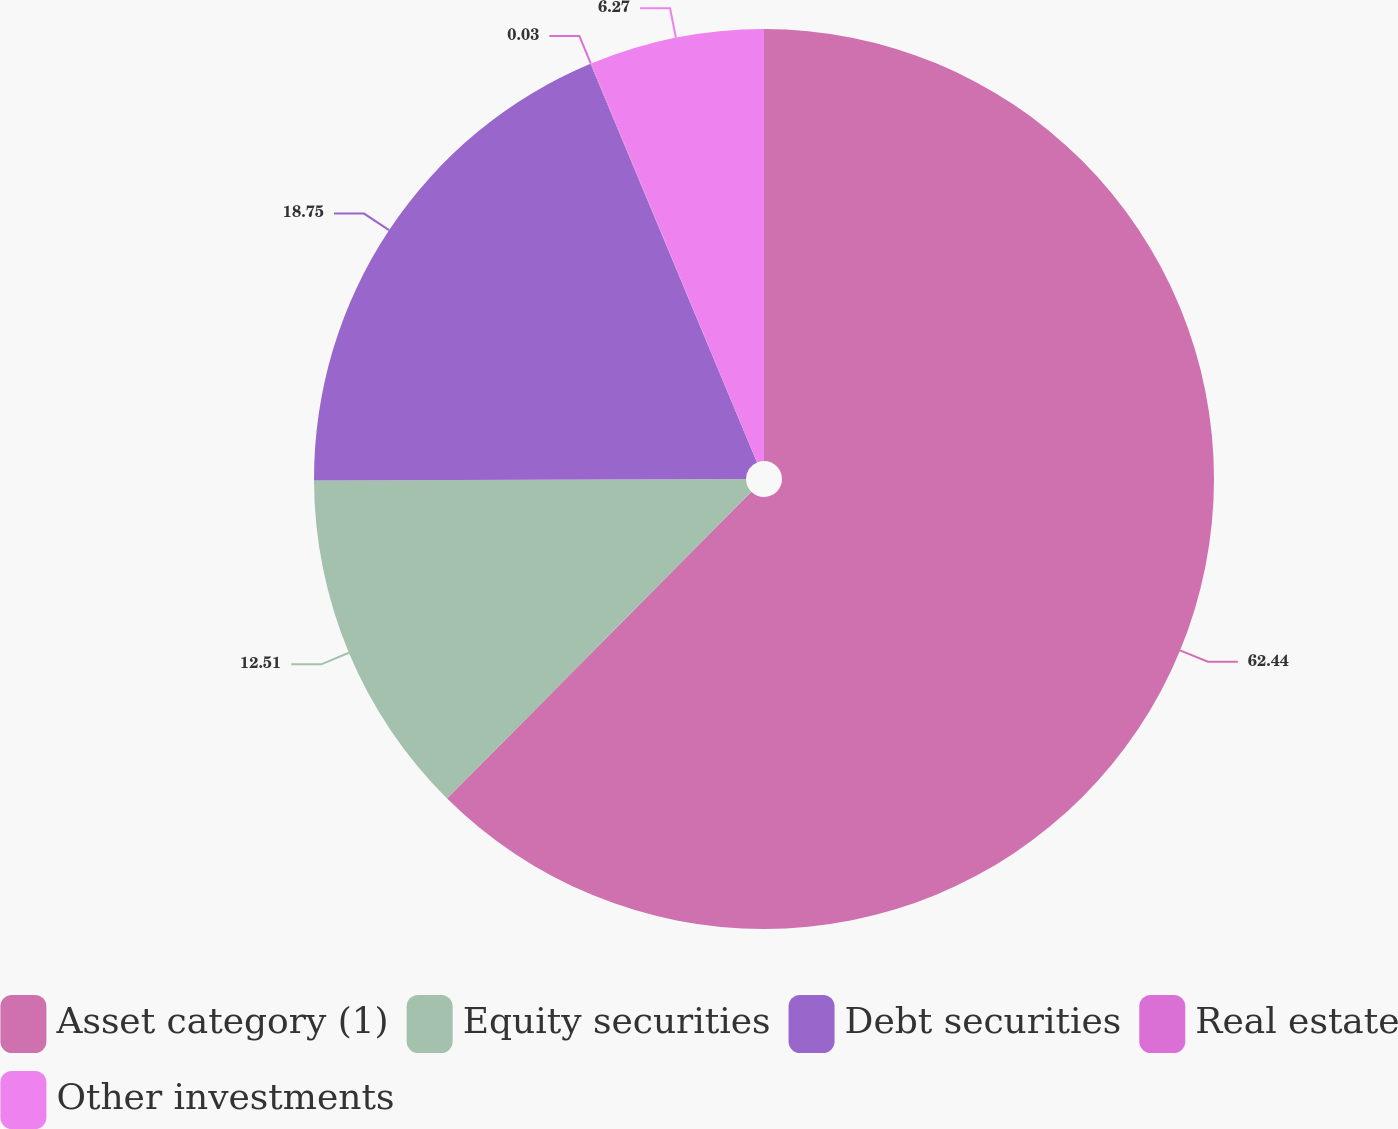<chart> <loc_0><loc_0><loc_500><loc_500><pie_chart><fcel>Asset category (1)<fcel>Equity securities<fcel>Debt securities<fcel>Real estate<fcel>Other investments<nl><fcel>62.43%<fcel>12.51%<fcel>18.75%<fcel>0.03%<fcel>6.27%<nl></chart> 